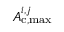<formula> <loc_0><loc_0><loc_500><loc_500>A _ { c , \max } ^ { i , j }</formula> 